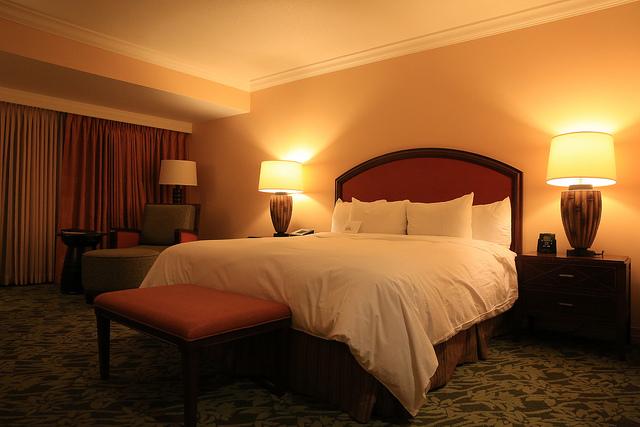Does this room have a clock?
Answer briefly. Yes. How many lampshades are maroon?
Write a very short answer. 0. How many lamps are on?
Concise answer only. 2. What kind of bed is in the picture?
Write a very short answer. King. Is this a hotel room?
Write a very short answer. Yes. 